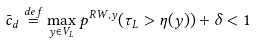<formula> <loc_0><loc_0><loc_500><loc_500>\bar { c } _ { d } \overset { d e f } { = } \max _ { y \in V _ { L } } p ^ { R W , y } ( \tau _ { L } > \eta ( y ) ) + \delta < 1</formula> 